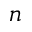<formula> <loc_0><loc_0><loc_500><loc_500>n</formula> 